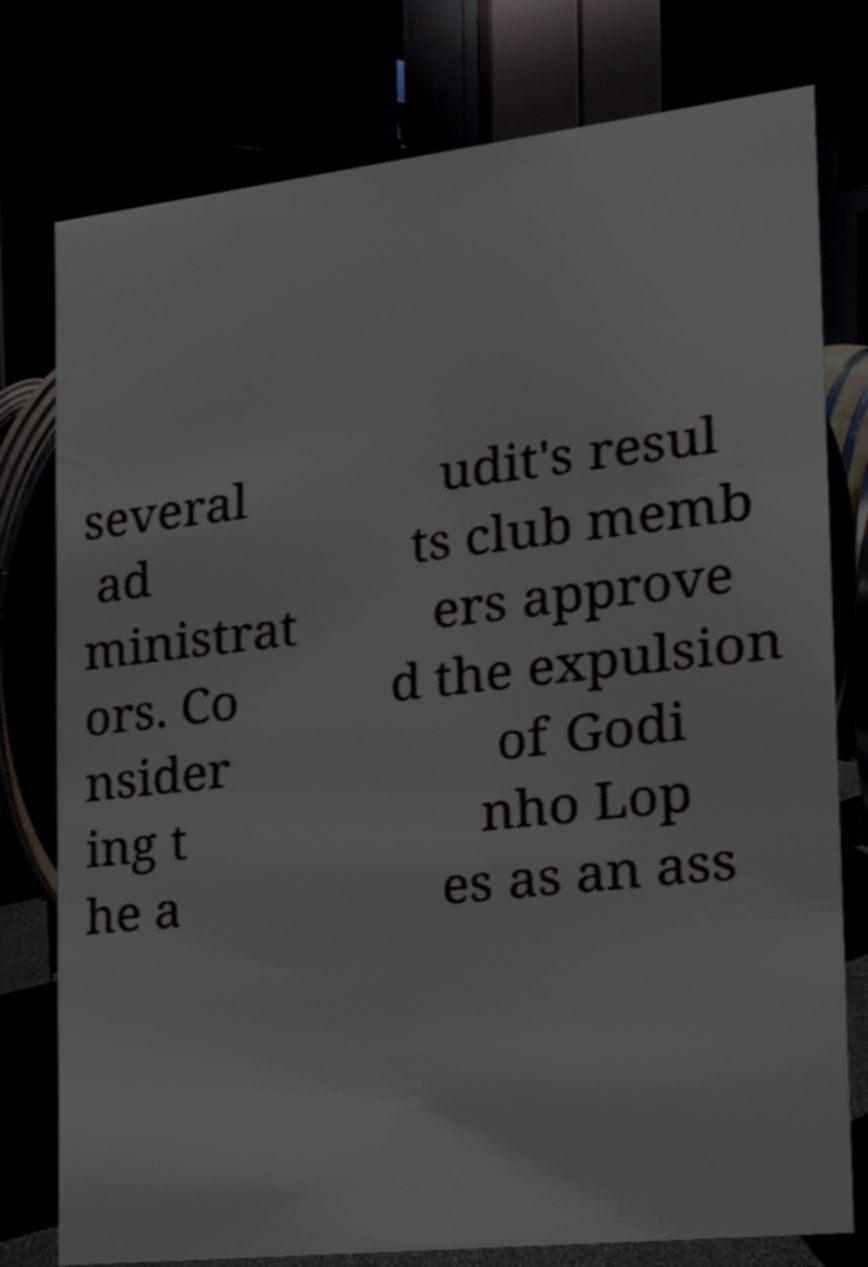I need the written content from this picture converted into text. Can you do that? several ad ministrat ors. Co nsider ing t he a udit's resul ts club memb ers approve d the expulsion of Godi nho Lop es as an ass 